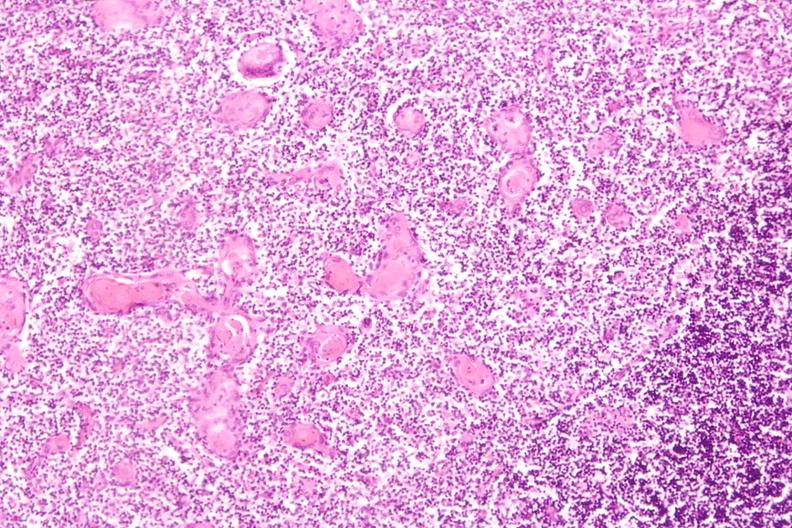what induce involution in baby with hyaline membrane disease?
Answer the question using a single word or phrase. Stress 